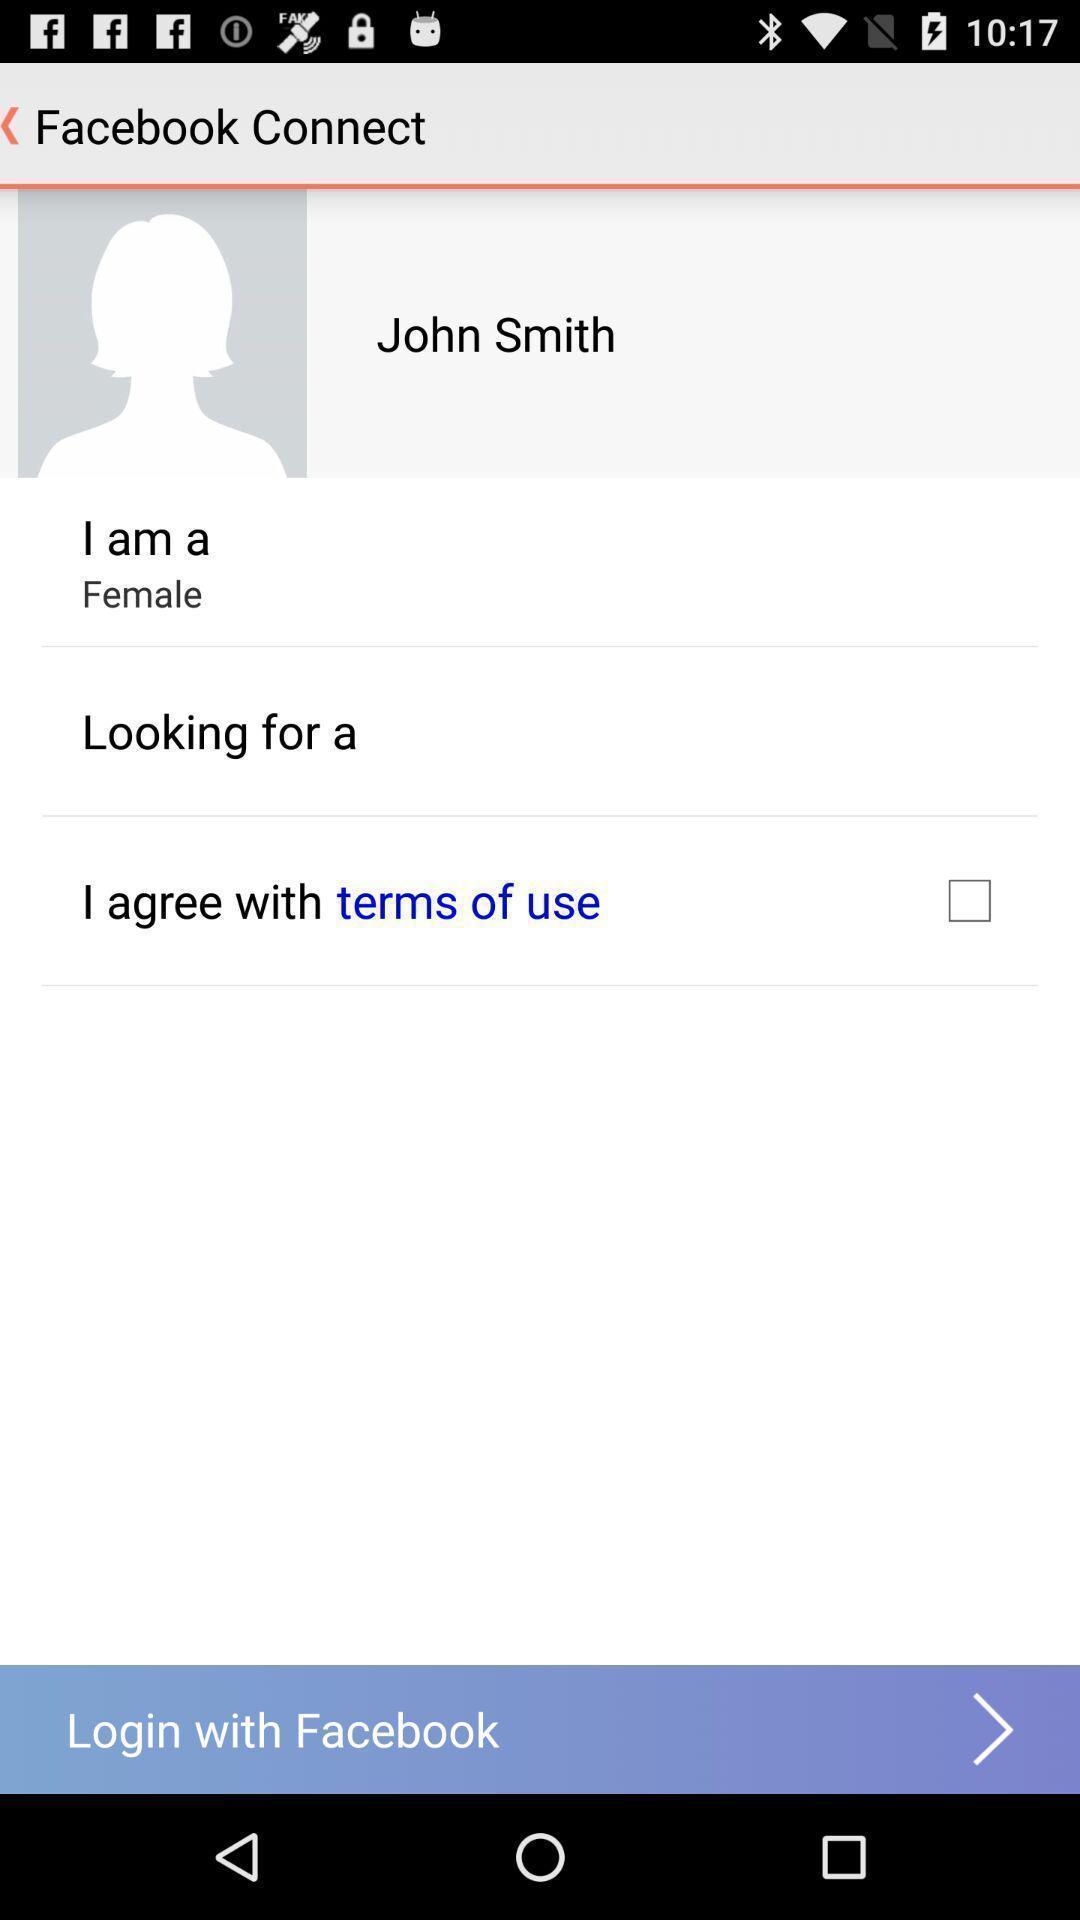Please provide a description for this image. Screen displaying the profile page in a social app. 